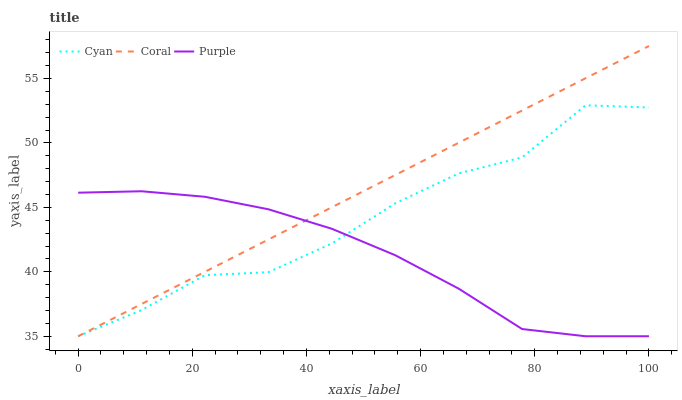Does Purple have the minimum area under the curve?
Answer yes or no. Yes. Does Coral have the maximum area under the curve?
Answer yes or no. Yes. Does Cyan have the minimum area under the curve?
Answer yes or no. No. Does Cyan have the maximum area under the curve?
Answer yes or no. No. Is Coral the smoothest?
Answer yes or no. Yes. Is Cyan the roughest?
Answer yes or no. Yes. Is Cyan the smoothest?
Answer yes or no. No. Is Coral the roughest?
Answer yes or no. No. Does Purple have the lowest value?
Answer yes or no. Yes. Does Coral have the highest value?
Answer yes or no. Yes. Does Cyan have the highest value?
Answer yes or no. No. Does Coral intersect Purple?
Answer yes or no. Yes. Is Coral less than Purple?
Answer yes or no. No. Is Coral greater than Purple?
Answer yes or no. No. 